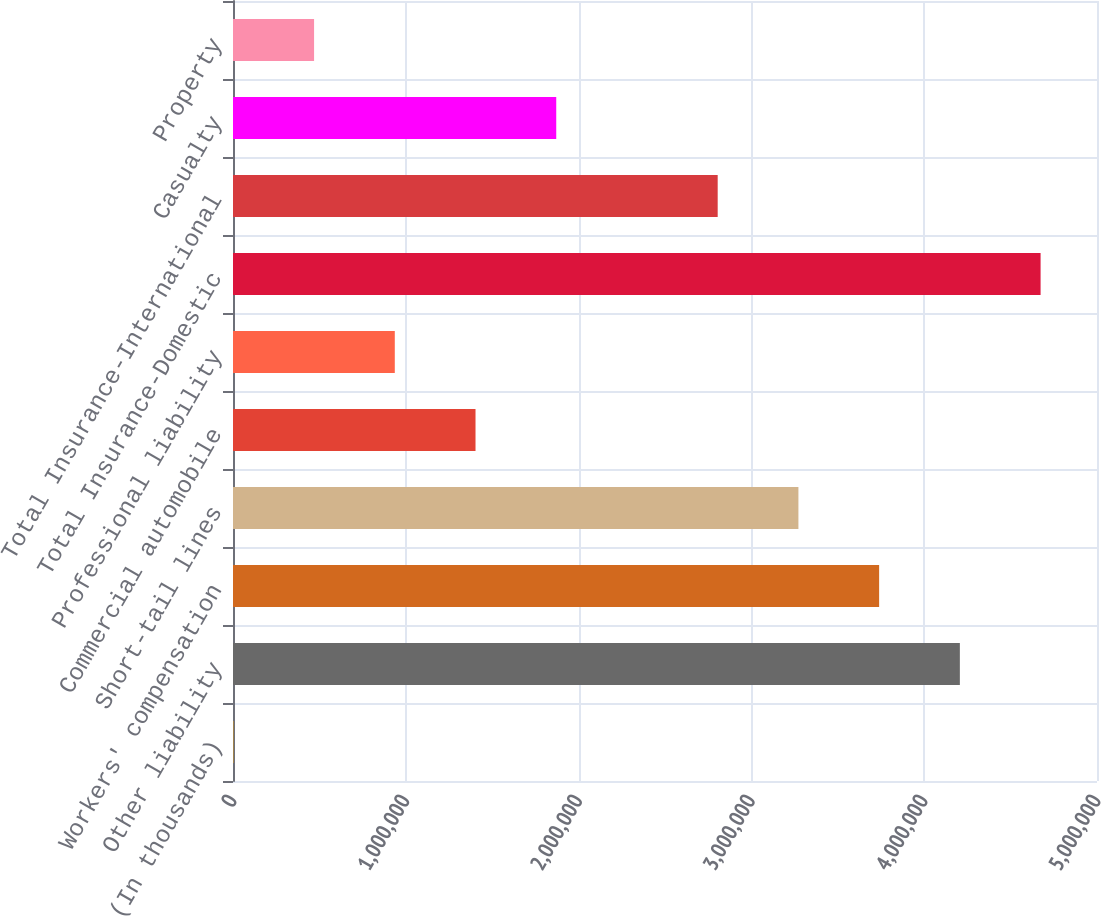Convert chart to OTSL. <chart><loc_0><loc_0><loc_500><loc_500><bar_chart><fcel>(In thousands)<fcel>Other liability<fcel>Workers' compensation<fcel>Short-tail lines<fcel>Commercial automobile<fcel>Professional liability<fcel>Total Insurance-Domestic<fcel>Total Insurance-International<fcel>Casualty<fcel>Property<nl><fcel>2012<fcel>4.20637e+06<fcel>3.73922e+06<fcel>3.27206e+06<fcel>1.40346e+06<fcel>936313<fcel>4.67352e+06<fcel>2.80491e+06<fcel>1.87061e+06<fcel>469162<nl></chart> 